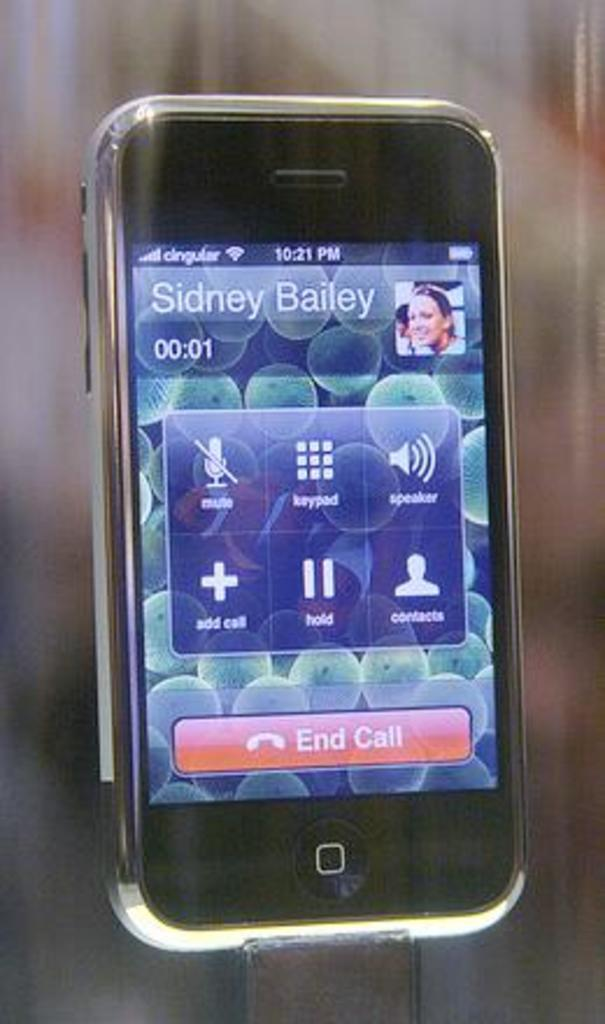<image>
Give a short and clear explanation of the subsequent image. Sidney Bailey has been on a call with the owner of this phone for one second. 